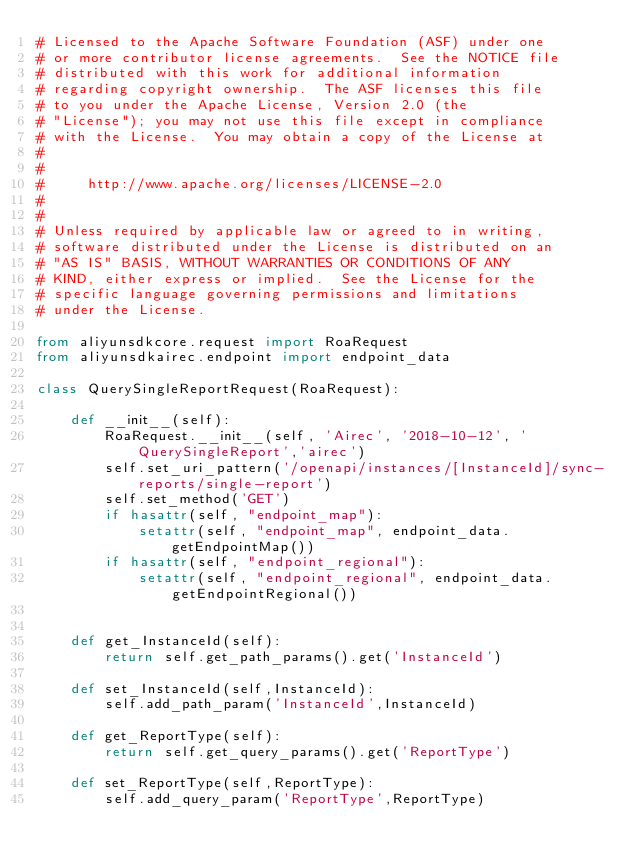<code> <loc_0><loc_0><loc_500><loc_500><_Python_># Licensed to the Apache Software Foundation (ASF) under one
# or more contributor license agreements.  See the NOTICE file
# distributed with this work for additional information
# regarding copyright ownership.  The ASF licenses this file
# to you under the Apache License, Version 2.0 (the
# "License"); you may not use this file except in compliance
# with the License.  You may obtain a copy of the License at
#
#
#     http://www.apache.org/licenses/LICENSE-2.0
#
#
# Unless required by applicable law or agreed to in writing,
# software distributed under the License is distributed on an
# "AS IS" BASIS, WITHOUT WARRANTIES OR CONDITIONS OF ANY
# KIND, either express or implied.  See the License for the
# specific language governing permissions and limitations
# under the License.

from aliyunsdkcore.request import RoaRequest
from aliyunsdkairec.endpoint import endpoint_data

class QuerySingleReportRequest(RoaRequest):

	def __init__(self):
		RoaRequest.__init__(self, 'Airec', '2018-10-12', 'QuerySingleReport','airec')
		self.set_uri_pattern('/openapi/instances/[InstanceId]/sync-reports/single-report')
		self.set_method('GET')
		if hasattr(self, "endpoint_map"):
			setattr(self, "endpoint_map", endpoint_data.getEndpointMap())
		if hasattr(self, "endpoint_regional"):
			setattr(self, "endpoint_regional", endpoint_data.getEndpointRegional())


	def get_InstanceId(self):
		return self.get_path_params().get('InstanceId')

	def set_InstanceId(self,InstanceId):
		self.add_path_param('InstanceId',InstanceId)

	def get_ReportType(self):
		return self.get_query_params().get('ReportType')

	def set_ReportType(self,ReportType):
		self.add_query_param('ReportType',ReportType)</code> 